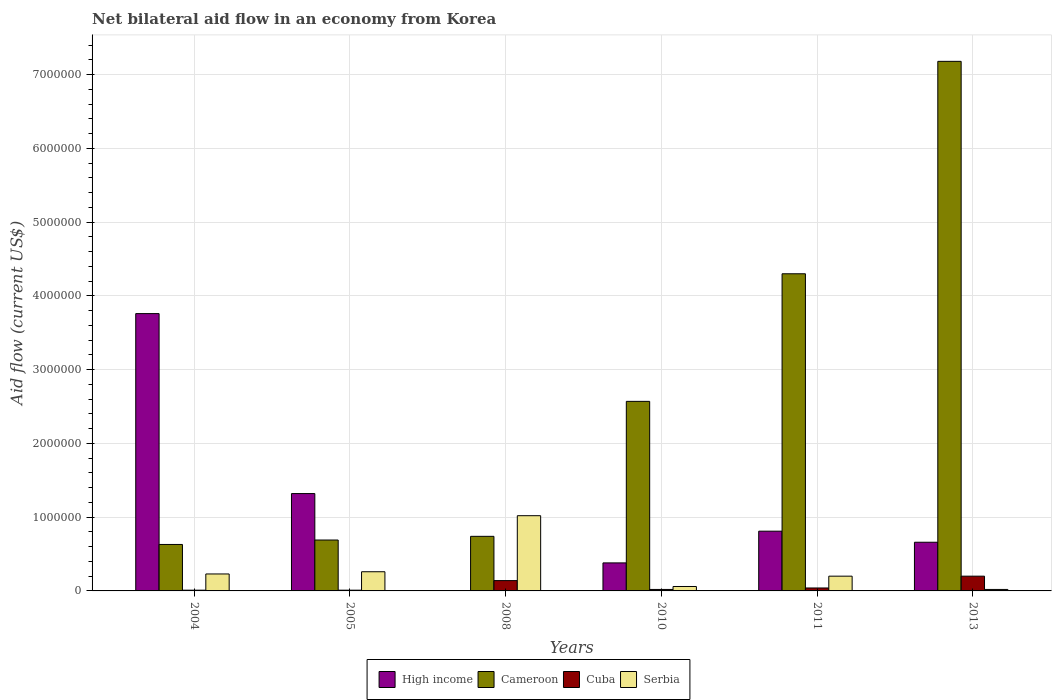How many bars are there on the 1st tick from the left?
Give a very brief answer. 4. What is the net bilateral aid flow in Cameroon in 2013?
Provide a succinct answer. 7.18e+06. Across all years, what is the maximum net bilateral aid flow in Serbia?
Offer a terse response. 1.02e+06. Across all years, what is the minimum net bilateral aid flow in Cameroon?
Keep it short and to the point. 6.30e+05. In which year was the net bilateral aid flow in Cameroon maximum?
Your answer should be very brief. 2013. What is the total net bilateral aid flow in High income in the graph?
Offer a terse response. 6.93e+06. What is the difference between the net bilateral aid flow in Serbia in 2008 and that in 2013?
Your answer should be very brief. 1.00e+06. What is the difference between the net bilateral aid flow in Cuba in 2011 and the net bilateral aid flow in Serbia in 2010?
Ensure brevity in your answer.  -2.00e+04. What is the average net bilateral aid flow in Serbia per year?
Keep it short and to the point. 2.98e+05. In the year 2008, what is the difference between the net bilateral aid flow in Cameroon and net bilateral aid flow in Cuba?
Your answer should be very brief. 6.00e+05. What is the ratio of the net bilateral aid flow in Serbia in 2004 to that in 2008?
Offer a very short reply. 0.23. Is the difference between the net bilateral aid flow in Cameroon in 2005 and 2010 greater than the difference between the net bilateral aid flow in Cuba in 2005 and 2010?
Give a very brief answer. No. What is the difference between the highest and the second highest net bilateral aid flow in Cameroon?
Offer a terse response. 2.88e+06. What is the difference between the highest and the lowest net bilateral aid flow in Cuba?
Keep it short and to the point. 1.90e+05. In how many years, is the net bilateral aid flow in Serbia greater than the average net bilateral aid flow in Serbia taken over all years?
Provide a succinct answer. 1. Is the sum of the net bilateral aid flow in Cuba in 2010 and 2013 greater than the maximum net bilateral aid flow in High income across all years?
Offer a terse response. No. How many bars are there?
Your answer should be compact. 23. What is the difference between two consecutive major ticks on the Y-axis?
Offer a very short reply. 1.00e+06. Are the values on the major ticks of Y-axis written in scientific E-notation?
Ensure brevity in your answer.  No. Does the graph contain any zero values?
Provide a succinct answer. Yes. How are the legend labels stacked?
Give a very brief answer. Horizontal. What is the title of the graph?
Your answer should be compact. Net bilateral aid flow in an economy from Korea. What is the label or title of the Y-axis?
Your answer should be very brief. Aid flow (current US$). What is the Aid flow (current US$) of High income in 2004?
Provide a succinct answer. 3.76e+06. What is the Aid flow (current US$) in Cameroon in 2004?
Give a very brief answer. 6.30e+05. What is the Aid flow (current US$) in Cuba in 2004?
Offer a very short reply. 10000. What is the Aid flow (current US$) of Serbia in 2004?
Provide a succinct answer. 2.30e+05. What is the Aid flow (current US$) in High income in 2005?
Give a very brief answer. 1.32e+06. What is the Aid flow (current US$) in Cameroon in 2005?
Your response must be concise. 6.90e+05. What is the Aid flow (current US$) of High income in 2008?
Make the answer very short. 0. What is the Aid flow (current US$) of Cameroon in 2008?
Ensure brevity in your answer.  7.40e+05. What is the Aid flow (current US$) of Serbia in 2008?
Offer a terse response. 1.02e+06. What is the Aid flow (current US$) of High income in 2010?
Provide a short and direct response. 3.80e+05. What is the Aid flow (current US$) of Cameroon in 2010?
Your answer should be compact. 2.57e+06. What is the Aid flow (current US$) in Cuba in 2010?
Make the answer very short. 2.00e+04. What is the Aid flow (current US$) of High income in 2011?
Make the answer very short. 8.10e+05. What is the Aid flow (current US$) of Cameroon in 2011?
Ensure brevity in your answer.  4.30e+06. What is the Aid flow (current US$) of Cuba in 2011?
Your response must be concise. 4.00e+04. What is the Aid flow (current US$) in Serbia in 2011?
Your response must be concise. 2.00e+05. What is the Aid flow (current US$) of High income in 2013?
Provide a short and direct response. 6.60e+05. What is the Aid flow (current US$) in Cameroon in 2013?
Provide a succinct answer. 7.18e+06. What is the Aid flow (current US$) of Cuba in 2013?
Offer a terse response. 2.00e+05. Across all years, what is the maximum Aid flow (current US$) of High income?
Provide a succinct answer. 3.76e+06. Across all years, what is the maximum Aid flow (current US$) of Cameroon?
Offer a very short reply. 7.18e+06. Across all years, what is the maximum Aid flow (current US$) in Cuba?
Keep it short and to the point. 2.00e+05. Across all years, what is the maximum Aid flow (current US$) of Serbia?
Provide a short and direct response. 1.02e+06. Across all years, what is the minimum Aid flow (current US$) in Cameroon?
Your response must be concise. 6.30e+05. Across all years, what is the minimum Aid flow (current US$) of Cuba?
Provide a succinct answer. 10000. Across all years, what is the minimum Aid flow (current US$) of Serbia?
Provide a short and direct response. 2.00e+04. What is the total Aid flow (current US$) of High income in the graph?
Offer a very short reply. 6.93e+06. What is the total Aid flow (current US$) in Cameroon in the graph?
Give a very brief answer. 1.61e+07. What is the total Aid flow (current US$) in Cuba in the graph?
Keep it short and to the point. 4.20e+05. What is the total Aid flow (current US$) of Serbia in the graph?
Offer a very short reply. 1.79e+06. What is the difference between the Aid flow (current US$) of High income in 2004 and that in 2005?
Provide a succinct answer. 2.44e+06. What is the difference between the Aid flow (current US$) of Serbia in 2004 and that in 2005?
Offer a terse response. -3.00e+04. What is the difference between the Aid flow (current US$) in Cameroon in 2004 and that in 2008?
Make the answer very short. -1.10e+05. What is the difference between the Aid flow (current US$) in Serbia in 2004 and that in 2008?
Offer a very short reply. -7.90e+05. What is the difference between the Aid flow (current US$) in High income in 2004 and that in 2010?
Offer a very short reply. 3.38e+06. What is the difference between the Aid flow (current US$) in Cameroon in 2004 and that in 2010?
Keep it short and to the point. -1.94e+06. What is the difference between the Aid flow (current US$) in Cuba in 2004 and that in 2010?
Provide a succinct answer. -10000. What is the difference between the Aid flow (current US$) in Serbia in 2004 and that in 2010?
Your answer should be compact. 1.70e+05. What is the difference between the Aid flow (current US$) in High income in 2004 and that in 2011?
Provide a succinct answer. 2.95e+06. What is the difference between the Aid flow (current US$) in Cameroon in 2004 and that in 2011?
Provide a succinct answer. -3.67e+06. What is the difference between the Aid flow (current US$) in Cuba in 2004 and that in 2011?
Your answer should be very brief. -3.00e+04. What is the difference between the Aid flow (current US$) in Serbia in 2004 and that in 2011?
Your answer should be very brief. 3.00e+04. What is the difference between the Aid flow (current US$) of High income in 2004 and that in 2013?
Make the answer very short. 3.10e+06. What is the difference between the Aid flow (current US$) of Cameroon in 2004 and that in 2013?
Make the answer very short. -6.55e+06. What is the difference between the Aid flow (current US$) of Cameroon in 2005 and that in 2008?
Your response must be concise. -5.00e+04. What is the difference between the Aid flow (current US$) in Serbia in 2005 and that in 2008?
Your response must be concise. -7.60e+05. What is the difference between the Aid flow (current US$) of High income in 2005 and that in 2010?
Provide a short and direct response. 9.40e+05. What is the difference between the Aid flow (current US$) of Cameroon in 2005 and that in 2010?
Your answer should be compact. -1.88e+06. What is the difference between the Aid flow (current US$) in High income in 2005 and that in 2011?
Your answer should be compact. 5.10e+05. What is the difference between the Aid flow (current US$) in Cameroon in 2005 and that in 2011?
Keep it short and to the point. -3.61e+06. What is the difference between the Aid flow (current US$) in Cuba in 2005 and that in 2011?
Make the answer very short. -3.00e+04. What is the difference between the Aid flow (current US$) in Serbia in 2005 and that in 2011?
Your answer should be very brief. 6.00e+04. What is the difference between the Aid flow (current US$) of High income in 2005 and that in 2013?
Your response must be concise. 6.60e+05. What is the difference between the Aid flow (current US$) in Cameroon in 2005 and that in 2013?
Your response must be concise. -6.49e+06. What is the difference between the Aid flow (current US$) in Serbia in 2005 and that in 2013?
Offer a terse response. 2.40e+05. What is the difference between the Aid flow (current US$) of Cameroon in 2008 and that in 2010?
Offer a terse response. -1.83e+06. What is the difference between the Aid flow (current US$) in Cuba in 2008 and that in 2010?
Keep it short and to the point. 1.20e+05. What is the difference between the Aid flow (current US$) of Serbia in 2008 and that in 2010?
Your response must be concise. 9.60e+05. What is the difference between the Aid flow (current US$) in Cameroon in 2008 and that in 2011?
Your answer should be compact. -3.56e+06. What is the difference between the Aid flow (current US$) of Cuba in 2008 and that in 2011?
Your response must be concise. 1.00e+05. What is the difference between the Aid flow (current US$) in Serbia in 2008 and that in 2011?
Your answer should be very brief. 8.20e+05. What is the difference between the Aid flow (current US$) in Cameroon in 2008 and that in 2013?
Make the answer very short. -6.44e+06. What is the difference between the Aid flow (current US$) of Cuba in 2008 and that in 2013?
Provide a succinct answer. -6.00e+04. What is the difference between the Aid flow (current US$) in High income in 2010 and that in 2011?
Keep it short and to the point. -4.30e+05. What is the difference between the Aid flow (current US$) of Cameroon in 2010 and that in 2011?
Keep it short and to the point. -1.73e+06. What is the difference between the Aid flow (current US$) of Cuba in 2010 and that in 2011?
Provide a short and direct response. -2.00e+04. What is the difference between the Aid flow (current US$) in High income in 2010 and that in 2013?
Offer a very short reply. -2.80e+05. What is the difference between the Aid flow (current US$) of Cameroon in 2010 and that in 2013?
Give a very brief answer. -4.61e+06. What is the difference between the Aid flow (current US$) of Cameroon in 2011 and that in 2013?
Provide a short and direct response. -2.88e+06. What is the difference between the Aid flow (current US$) of Serbia in 2011 and that in 2013?
Provide a short and direct response. 1.80e+05. What is the difference between the Aid flow (current US$) in High income in 2004 and the Aid flow (current US$) in Cameroon in 2005?
Make the answer very short. 3.07e+06. What is the difference between the Aid flow (current US$) of High income in 2004 and the Aid flow (current US$) of Cuba in 2005?
Provide a succinct answer. 3.75e+06. What is the difference between the Aid flow (current US$) of High income in 2004 and the Aid flow (current US$) of Serbia in 2005?
Give a very brief answer. 3.50e+06. What is the difference between the Aid flow (current US$) of Cameroon in 2004 and the Aid flow (current US$) of Cuba in 2005?
Offer a terse response. 6.20e+05. What is the difference between the Aid flow (current US$) in Cameroon in 2004 and the Aid flow (current US$) in Serbia in 2005?
Give a very brief answer. 3.70e+05. What is the difference between the Aid flow (current US$) in Cuba in 2004 and the Aid flow (current US$) in Serbia in 2005?
Offer a very short reply. -2.50e+05. What is the difference between the Aid flow (current US$) of High income in 2004 and the Aid flow (current US$) of Cameroon in 2008?
Provide a succinct answer. 3.02e+06. What is the difference between the Aid flow (current US$) in High income in 2004 and the Aid flow (current US$) in Cuba in 2008?
Keep it short and to the point. 3.62e+06. What is the difference between the Aid flow (current US$) of High income in 2004 and the Aid flow (current US$) of Serbia in 2008?
Give a very brief answer. 2.74e+06. What is the difference between the Aid flow (current US$) in Cameroon in 2004 and the Aid flow (current US$) in Serbia in 2008?
Give a very brief answer. -3.90e+05. What is the difference between the Aid flow (current US$) in Cuba in 2004 and the Aid flow (current US$) in Serbia in 2008?
Keep it short and to the point. -1.01e+06. What is the difference between the Aid flow (current US$) of High income in 2004 and the Aid flow (current US$) of Cameroon in 2010?
Offer a very short reply. 1.19e+06. What is the difference between the Aid flow (current US$) of High income in 2004 and the Aid flow (current US$) of Cuba in 2010?
Your answer should be very brief. 3.74e+06. What is the difference between the Aid flow (current US$) in High income in 2004 and the Aid flow (current US$) in Serbia in 2010?
Make the answer very short. 3.70e+06. What is the difference between the Aid flow (current US$) of Cameroon in 2004 and the Aid flow (current US$) of Cuba in 2010?
Offer a very short reply. 6.10e+05. What is the difference between the Aid flow (current US$) of Cameroon in 2004 and the Aid flow (current US$) of Serbia in 2010?
Make the answer very short. 5.70e+05. What is the difference between the Aid flow (current US$) of Cuba in 2004 and the Aid flow (current US$) of Serbia in 2010?
Offer a terse response. -5.00e+04. What is the difference between the Aid flow (current US$) of High income in 2004 and the Aid flow (current US$) of Cameroon in 2011?
Give a very brief answer. -5.40e+05. What is the difference between the Aid flow (current US$) in High income in 2004 and the Aid flow (current US$) in Cuba in 2011?
Your answer should be compact. 3.72e+06. What is the difference between the Aid flow (current US$) of High income in 2004 and the Aid flow (current US$) of Serbia in 2011?
Your answer should be very brief. 3.56e+06. What is the difference between the Aid flow (current US$) in Cameroon in 2004 and the Aid flow (current US$) in Cuba in 2011?
Your response must be concise. 5.90e+05. What is the difference between the Aid flow (current US$) of Cuba in 2004 and the Aid flow (current US$) of Serbia in 2011?
Provide a short and direct response. -1.90e+05. What is the difference between the Aid flow (current US$) of High income in 2004 and the Aid flow (current US$) of Cameroon in 2013?
Keep it short and to the point. -3.42e+06. What is the difference between the Aid flow (current US$) of High income in 2004 and the Aid flow (current US$) of Cuba in 2013?
Your response must be concise. 3.56e+06. What is the difference between the Aid flow (current US$) of High income in 2004 and the Aid flow (current US$) of Serbia in 2013?
Keep it short and to the point. 3.74e+06. What is the difference between the Aid flow (current US$) of Cameroon in 2004 and the Aid flow (current US$) of Serbia in 2013?
Provide a succinct answer. 6.10e+05. What is the difference between the Aid flow (current US$) of Cuba in 2004 and the Aid flow (current US$) of Serbia in 2013?
Ensure brevity in your answer.  -10000. What is the difference between the Aid flow (current US$) of High income in 2005 and the Aid flow (current US$) of Cameroon in 2008?
Keep it short and to the point. 5.80e+05. What is the difference between the Aid flow (current US$) in High income in 2005 and the Aid flow (current US$) in Cuba in 2008?
Provide a succinct answer. 1.18e+06. What is the difference between the Aid flow (current US$) of Cameroon in 2005 and the Aid flow (current US$) of Cuba in 2008?
Ensure brevity in your answer.  5.50e+05. What is the difference between the Aid flow (current US$) in Cameroon in 2005 and the Aid flow (current US$) in Serbia in 2008?
Your response must be concise. -3.30e+05. What is the difference between the Aid flow (current US$) in Cuba in 2005 and the Aid flow (current US$) in Serbia in 2008?
Your answer should be very brief. -1.01e+06. What is the difference between the Aid flow (current US$) in High income in 2005 and the Aid flow (current US$) in Cameroon in 2010?
Provide a short and direct response. -1.25e+06. What is the difference between the Aid flow (current US$) of High income in 2005 and the Aid flow (current US$) of Cuba in 2010?
Provide a succinct answer. 1.30e+06. What is the difference between the Aid flow (current US$) in High income in 2005 and the Aid flow (current US$) in Serbia in 2010?
Make the answer very short. 1.26e+06. What is the difference between the Aid flow (current US$) of Cameroon in 2005 and the Aid flow (current US$) of Cuba in 2010?
Your answer should be compact. 6.70e+05. What is the difference between the Aid flow (current US$) of Cameroon in 2005 and the Aid flow (current US$) of Serbia in 2010?
Ensure brevity in your answer.  6.30e+05. What is the difference between the Aid flow (current US$) of High income in 2005 and the Aid flow (current US$) of Cameroon in 2011?
Give a very brief answer. -2.98e+06. What is the difference between the Aid flow (current US$) of High income in 2005 and the Aid flow (current US$) of Cuba in 2011?
Make the answer very short. 1.28e+06. What is the difference between the Aid flow (current US$) of High income in 2005 and the Aid flow (current US$) of Serbia in 2011?
Provide a succinct answer. 1.12e+06. What is the difference between the Aid flow (current US$) in Cameroon in 2005 and the Aid flow (current US$) in Cuba in 2011?
Your response must be concise. 6.50e+05. What is the difference between the Aid flow (current US$) of Cameroon in 2005 and the Aid flow (current US$) of Serbia in 2011?
Your answer should be compact. 4.90e+05. What is the difference between the Aid flow (current US$) in Cuba in 2005 and the Aid flow (current US$) in Serbia in 2011?
Your answer should be very brief. -1.90e+05. What is the difference between the Aid flow (current US$) in High income in 2005 and the Aid flow (current US$) in Cameroon in 2013?
Ensure brevity in your answer.  -5.86e+06. What is the difference between the Aid flow (current US$) of High income in 2005 and the Aid flow (current US$) of Cuba in 2013?
Your answer should be very brief. 1.12e+06. What is the difference between the Aid flow (current US$) in High income in 2005 and the Aid flow (current US$) in Serbia in 2013?
Make the answer very short. 1.30e+06. What is the difference between the Aid flow (current US$) in Cameroon in 2005 and the Aid flow (current US$) in Cuba in 2013?
Offer a terse response. 4.90e+05. What is the difference between the Aid flow (current US$) in Cameroon in 2005 and the Aid flow (current US$) in Serbia in 2013?
Offer a very short reply. 6.70e+05. What is the difference between the Aid flow (current US$) in Cuba in 2005 and the Aid flow (current US$) in Serbia in 2013?
Provide a short and direct response. -10000. What is the difference between the Aid flow (current US$) of Cameroon in 2008 and the Aid flow (current US$) of Cuba in 2010?
Provide a succinct answer. 7.20e+05. What is the difference between the Aid flow (current US$) in Cameroon in 2008 and the Aid flow (current US$) in Serbia in 2010?
Offer a very short reply. 6.80e+05. What is the difference between the Aid flow (current US$) of Cameroon in 2008 and the Aid flow (current US$) of Cuba in 2011?
Your answer should be compact. 7.00e+05. What is the difference between the Aid flow (current US$) in Cameroon in 2008 and the Aid flow (current US$) in Serbia in 2011?
Your answer should be compact. 5.40e+05. What is the difference between the Aid flow (current US$) of Cameroon in 2008 and the Aid flow (current US$) of Cuba in 2013?
Offer a very short reply. 5.40e+05. What is the difference between the Aid flow (current US$) of Cameroon in 2008 and the Aid flow (current US$) of Serbia in 2013?
Offer a terse response. 7.20e+05. What is the difference between the Aid flow (current US$) in High income in 2010 and the Aid flow (current US$) in Cameroon in 2011?
Your answer should be very brief. -3.92e+06. What is the difference between the Aid flow (current US$) in High income in 2010 and the Aid flow (current US$) in Cuba in 2011?
Your answer should be compact. 3.40e+05. What is the difference between the Aid flow (current US$) of High income in 2010 and the Aid flow (current US$) of Serbia in 2011?
Your response must be concise. 1.80e+05. What is the difference between the Aid flow (current US$) of Cameroon in 2010 and the Aid flow (current US$) of Cuba in 2011?
Give a very brief answer. 2.53e+06. What is the difference between the Aid flow (current US$) of Cameroon in 2010 and the Aid flow (current US$) of Serbia in 2011?
Your answer should be compact. 2.37e+06. What is the difference between the Aid flow (current US$) in Cuba in 2010 and the Aid flow (current US$) in Serbia in 2011?
Your response must be concise. -1.80e+05. What is the difference between the Aid flow (current US$) of High income in 2010 and the Aid flow (current US$) of Cameroon in 2013?
Your answer should be compact. -6.80e+06. What is the difference between the Aid flow (current US$) of High income in 2010 and the Aid flow (current US$) of Cuba in 2013?
Your answer should be compact. 1.80e+05. What is the difference between the Aid flow (current US$) of High income in 2010 and the Aid flow (current US$) of Serbia in 2013?
Offer a terse response. 3.60e+05. What is the difference between the Aid flow (current US$) of Cameroon in 2010 and the Aid flow (current US$) of Cuba in 2013?
Offer a terse response. 2.37e+06. What is the difference between the Aid flow (current US$) of Cameroon in 2010 and the Aid flow (current US$) of Serbia in 2013?
Provide a short and direct response. 2.55e+06. What is the difference between the Aid flow (current US$) of High income in 2011 and the Aid flow (current US$) of Cameroon in 2013?
Give a very brief answer. -6.37e+06. What is the difference between the Aid flow (current US$) in High income in 2011 and the Aid flow (current US$) in Cuba in 2013?
Your response must be concise. 6.10e+05. What is the difference between the Aid flow (current US$) of High income in 2011 and the Aid flow (current US$) of Serbia in 2013?
Keep it short and to the point. 7.90e+05. What is the difference between the Aid flow (current US$) of Cameroon in 2011 and the Aid flow (current US$) of Cuba in 2013?
Your answer should be compact. 4.10e+06. What is the difference between the Aid flow (current US$) of Cameroon in 2011 and the Aid flow (current US$) of Serbia in 2013?
Give a very brief answer. 4.28e+06. What is the average Aid flow (current US$) of High income per year?
Make the answer very short. 1.16e+06. What is the average Aid flow (current US$) of Cameroon per year?
Your response must be concise. 2.68e+06. What is the average Aid flow (current US$) of Serbia per year?
Offer a very short reply. 2.98e+05. In the year 2004, what is the difference between the Aid flow (current US$) of High income and Aid flow (current US$) of Cameroon?
Keep it short and to the point. 3.13e+06. In the year 2004, what is the difference between the Aid flow (current US$) in High income and Aid flow (current US$) in Cuba?
Offer a very short reply. 3.75e+06. In the year 2004, what is the difference between the Aid flow (current US$) in High income and Aid flow (current US$) in Serbia?
Your answer should be very brief. 3.53e+06. In the year 2004, what is the difference between the Aid flow (current US$) of Cameroon and Aid flow (current US$) of Cuba?
Provide a succinct answer. 6.20e+05. In the year 2004, what is the difference between the Aid flow (current US$) of Cameroon and Aid flow (current US$) of Serbia?
Provide a succinct answer. 4.00e+05. In the year 2004, what is the difference between the Aid flow (current US$) in Cuba and Aid flow (current US$) in Serbia?
Ensure brevity in your answer.  -2.20e+05. In the year 2005, what is the difference between the Aid flow (current US$) of High income and Aid flow (current US$) of Cameroon?
Offer a very short reply. 6.30e+05. In the year 2005, what is the difference between the Aid flow (current US$) of High income and Aid flow (current US$) of Cuba?
Your answer should be compact. 1.31e+06. In the year 2005, what is the difference between the Aid flow (current US$) in High income and Aid flow (current US$) in Serbia?
Offer a terse response. 1.06e+06. In the year 2005, what is the difference between the Aid flow (current US$) in Cameroon and Aid flow (current US$) in Cuba?
Give a very brief answer. 6.80e+05. In the year 2008, what is the difference between the Aid flow (current US$) in Cameroon and Aid flow (current US$) in Cuba?
Offer a very short reply. 6.00e+05. In the year 2008, what is the difference between the Aid flow (current US$) of Cameroon and Aid flow (current US$) of Serbia?
Your answer should be compact. -2.80e+05. In the year 2008, what is the difference between the Aid flow (current US$) in Cuba and Aid flow (current US$) in Serbia?
Keep it short and to the point. -8.80e+05. In the year 2010, what is the difference between the Aid flow (current US$) in High income and Aid flow (current US$) in Cameroon?
Give a very brief answer. -2.19e+06. In the year 2010, what is the difference between the Aid flow (current US$) in High income and Aid flow (current US$) in Cuba?
Provide a succinct answer. 3.60e+05. In the year 2010, what is the difference between the Aid flow (current US$) in High income and Aid flow (current US$) in Serbia?
Offer a very short reply. 3.20e+05. In the year 2010, what is the difference between the Aid flow (current US$) in Cameroon and Aid flow (current US$) in Cuba?
Make the answer very short. 2.55e+06. In the year 2010, what is the difference between the Aid flow (current US$) in Cameroon and Aid flow (current US$) in Serbia?
Offer a terse response. 2.51e+06. In the year 2010, what is the difference between the Aid flow (current US$) in Cuba and Aid flow (current US$) in Serbia?
Keep it short and to the point. -4.00e+04. In the year 2011, what is the difference between the Aid flow (current US$) in High income and Aid flow (current US$) in Cameroon?
Provide a short and direct response. -3.49e+06. In the year 2011, what is the difference between the Aid flow (current US$) of High income and Aid flow (current US$) of Cuba?
Offer a terse response. 7.70e+05. In the year 2011, what is the difference between the Aid flow (current US$) of High income and Aid flow (current US$) of Serbia?
Ensure brevity in your answer.  6.10e+05. In the year 2011, what is the difference between the Aid flow (current US$) of Cameroon and Aid flow (current US$) of Cuba?
Offer a terse response. 4.26e+06. In the year 2011, what is the difference between the Aid flow (current US$) of Cameroon and Aid flow (current US$) of Serbia?
Your response must be concise. 4.10e+06. In the year 2011, what is the difference between the Aid flow (current US$) of Cuba and Aid flow (current US$) of Serbia?
Offer a terse response. -1.60e+05. In the year 2013, what is the difference between the Aid flow (current US$) in High income and Aid flow (current US$) in Cameroon?
Your answer should be compact. -6.52e+06. In the year 2013, what is the difference between the Aid flow (current US$) in High income and Aid flow (current US$) in Cuba?
Your response must be concise. 4.60e+05. In the year 2013, what is the difference between the Aid flow (current US$) of High income and Aid flow (current US$) of Serbia?
Your response must be concise. 6.40e+05. In the year 2013, what is the difference between the Aid flow (current US$) of Cameroon and Aid flow (current US$) of Cuba?
Your response must be concise. 6.98e+06. In the year 2013, what is the difference between the Aid flow (current US$) in Cameroon and Aid flow (current US$) in Serbia?
Your answer should be compact. 7.16e+06. What is the ratio of the Aid flow (current US$) of High income in 2004 to that in 2005?
Keep it short and to the point. 2.85. What is the ratio of the Aid flow (current US$) of Cuba in 2004 to that in 2005?
Your answer should be very brief. 1. What is the ratio of the Aid flow (current US$) in Serbia in 2004 to that in 2005?
Offer a very short reply. 0.88. What is the ratio of the Aid flow (current US$) of Cameroon in 2004 to that in 2008?
Provide a short and direct response. 0.85. What is the ratio of the Aid flow (current US$) of Cuba in 2004 to that in 2008?
Keep it short and to the point. 0.07. What is the ratio of the Aid flow (current US$) of Serbia in 2004 to that in 2008?
Make the answer very short. 0.23. What is the ratio of the Aid flow (current US$) in High income in 2004 to that in 2010?
Provide a succinct answer. 9.89. What is the ratio of the Aid flow (current US$) of Cameroon in 2004 to that in 2010?
Offer a terse response. 0.25. What is the ratio of the Aid flow (current US$) of Serbia in 2004 to that in 2010?
Provide a short and direct response. 3.83. What is the ratio of the Aid flow (current US$) in High income in 2004 to that in 2011?
Your response must be concise. 4.64. What is the ratio of the Aid flow (current US$) of Cameroon in 2004 to that in 2011?
Your answer should be compact. 0.15. What is the ratio of the Aid flow (current US$) in Serbia in 2004 to that in 2011?
Your answer should be compact. 1.15. What is the ratio of the Aid flow (current US$) in High income in 2004 to that in 2013?
Offer a terse response. 5.7. What is the ratio of the Aid flow (current US$) of Cameroon in 2004 to that in 2013?
Your answer should be compact. 0.09. What is the ratio of the Aid flow (current US$) in Cameroon in 2005 to that in 2008?
Keep it short and to the point. 0.93. What is the ratio of the Aid flow (current US$) of Cuba in 2005 to that in 2008?
Offer a very short reply. 0.07. What is the ratio of the Aid flow (current US$) of Serbia in 2005 to that in 2008?
Your answer should be very brief. 0.25. What is the ratio of the Aid flow (current US$) in High income in 2005 to that in 2010?
Your response must be concise. 3.47. What is the ratio of the Aid flow (current US$) in Cameroon in 2005 to that in 2010?
Your answer should be very brief. 0.27. What is the ratio of the Aid flow (current US$) in Serbia in 2005 to that in 2010?
Provide a short and direct response. 4.33. What is the ratio of the Aid flow (current US$) of High income in 2005 to that in 2011?
Provide a short and direct response. 1.63. What is the ratio of the Aid flow (current US$) in Cameroon in 2005 to that in 2011?
Provide a short and direct response. 0.16. What is the ratio of the Aid flow (current US$) in Serbia in 2005 to that in 2011?
Your response must be concise. 1.3. What is the ratio of the Aid flow (current US$) in High income in 2005 to that in 2013?
Your response must be concise. 2. What is the ratio of the Aid flow (current US$) in Cameroon in 2005 to that in 2013?
Your answer should be very brief. 0.1. What is the ratio of the Aid flow (current US$) in Cuba in 2005 to that in 2013?
Give a very brief answer. 0.05. What is the ratio of the Aid flow (current US$) of Serbia in 2005 to that in 2013?
Make the answer very short. 13. What is the ratio of the Aid flow (current US$) of Cameroon in 2008 to that in 2010?
Your answer should be very brief. 0.29. What is the ratio of the Aid flow (current US$) in Cameroon in 2008 to that in 2011?
Give a very brief answer. 0.17. What is the ratio of the Aid flow (current US$) in Cuba in 2008 to that in 2011?
Your answer should be compact. 3.5. What is the ratio of the Aid flow (current US$) of Cameroon in 2008 to that in 2013?
Make the answer very short. 0.1. What is the ratio of the Aid flow (current US$) of High income in 2010 to that in 2011?
Provide a short and direct response. 0.47. What is the ratio of the Aid flow (current US$) of Cameroon in 2010 to that in 2011?
Keep it short and to the point. 0.6. What is the ratio of the Aid flow (current US$) in High income in 2010 to that in 2013?
Your answer should be compact. 0.58. What is the ratio of the Aid flow (current US$) of Cameroon in 2010 to that in 2013?
Give a very brief answer. 0.36. What is the ratio of the Aid flow (current US$) of High income in 2011 to that in 2013?
Your answer should be compact. 1.23. What is the ratio of the Aid flow (current US$) of Cameroon in 2011 to that in 2013?
Give a very brief answer. 0.6. What is the ratio of the Aid flow (current US$) in Cuba in 2011 to that in 2013?
Make the answer very short. 0.2. What is the ratio of the Aid flow (current US$) in Serbia in 2011 to that in 2013?
Offer a terse response. 10. What is the difference between the highest and the second highest Aid flow (current US$) in High income?
Provide a short and direct response. 2.44e+06. What is the difference between the highest and the second highest Aid flow (current US$) of Cameroon?
Offer a terse response. 2.88e+06. What is the difference between the highest and the second highest Aid flow (current US$) in Cuba?
Your response must be concise. 6.00e+04. What is the difference between the highest and the second highest Aid flow (current US$) of Serbia?
Your answer should be very brief. 7.60e+05. What is the difference between the highest and the lowest Aid flow (current US$) in High income?
Your answer should be compact. 3.76e+06. What is the difference between the highest and the lowest Aid flow (current US$) of Cameroon?
Provide a succinct answer. 6.55e+06. 